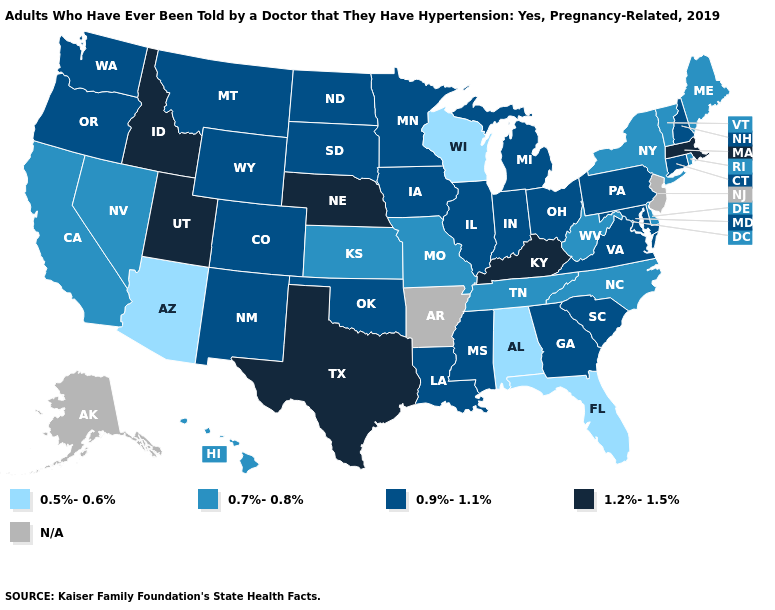Name the states that have a value in the range 0.5%-0.6%?
Be succinct. Alabama, Arizona, Florida, Wisconsin. Name the states that have a value in the range N/A?
Concise answer only. Alaska, Arkansas, New Jersey. Which states have the highest value in the USA?
Quick response, please. Idaho, Kentucky, Massachusetts, Nebraska, Texas, Utah. What is the highest value in states that border Arizona?
Be succinct. 1.2%-1.5%. Does the map have missing data?
Be succinct. Yes. What is the lowest value in the USA?
Write a very short answer. 0.5%-0.6%. Among the states that border Vermont , does New Hampshire have the lowest value?
Concise answer only. No. Name the states that have a value in the range 1.2%-1.5%?
Concise answer only. Idaho, Kentucky, Massachusetts, Nebraska, Texas, Utah. What is the value of Tennessee?
Be succinct. 0.7%-0.8%. How many symbols are there in the legend?
Quick response, please. 5. Does Wyoming have the highest value in the West?
Answer briefly. No. What is the value of Delaware?
Write a very short answer. 0.7%-0.8%. What is the value of Maine?
Write a very short answer. 0.7%-0.8%. Name the states that have a value in the range 0.5%-0.6%?
Write a very short answer. Alabama, Arizona, Florida, Wisconsin. 